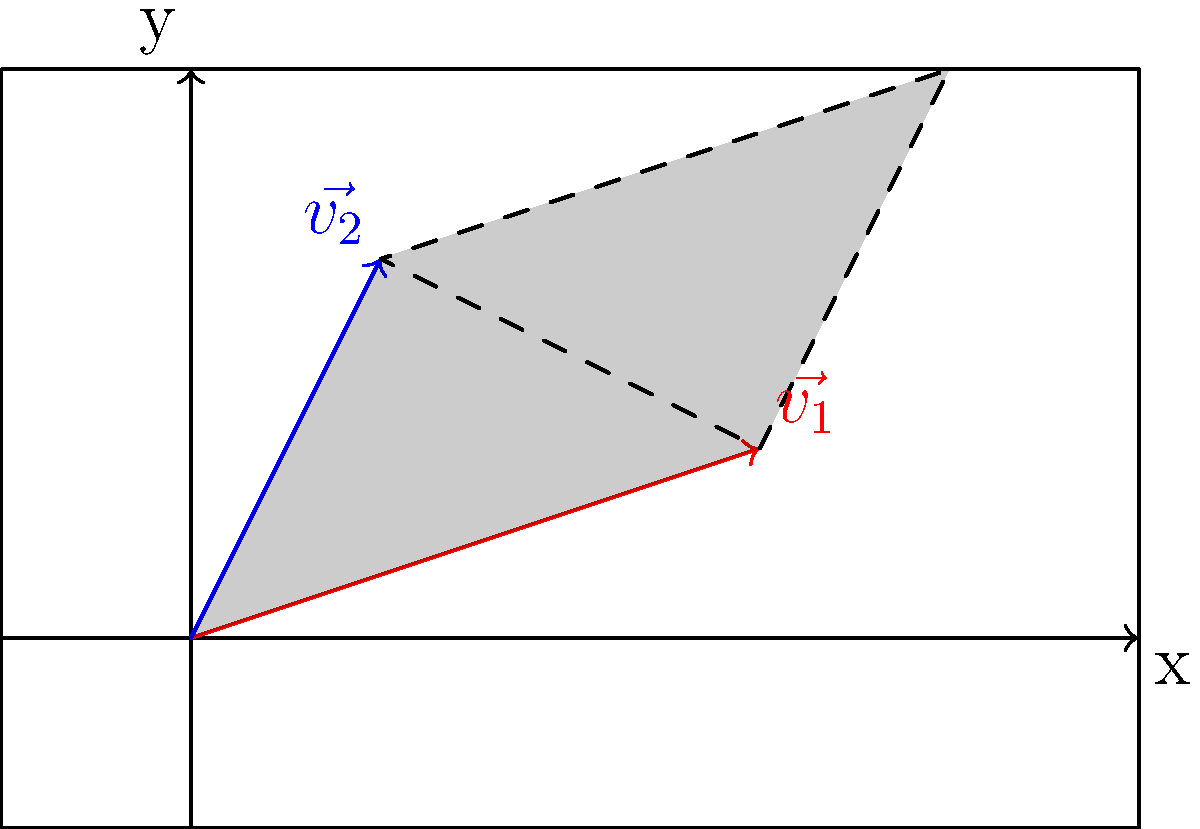In your greenhouse, you want to optimize the arrangement of two plant species that require different amounts of sunlight and water. You represent their growth requirements as vectors $\vec{v_1} = (3,1)$ and $\vec{v_2} = (1,2)$, where the x-axis represents sunlight needs and the y-axis represents water needs. What is the area of the parallelogram formed by these two vectors, which represents the total resource space for these plants? To find the area of the parallelogram formed by two vectors, we can use the magnitude of the cross product of these vectors. The steps are as follows:

1. Identify the vectors:
   $\vec{v_1} = (3,1)$ and $\vec{v_2} = (1,2)$

2. Calculate the cross product:
   $\vec{v_1} \times \vec{v_2} = (3 \cdot 2) - (1 \cdot 1) = 6 - 1 = 5$

3. The magnitude of the cross product gives the area of the parallelogram:
   Area = $|\vec{v_1} \times \vec{v_2}| = |5| = 5$

Therefore, the area of the parallelogram representing the total resource space for these plants is 5 square units.
Answer: 5 square units 